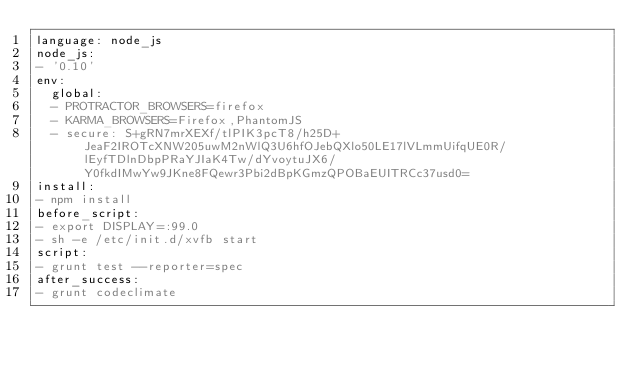<code> <loc_0><loc_0><loc_500><loc_500><_YAML_>language: node_js
node_js:
- '0.10'
env:
  global:
  - PROTRACTOR_BROWSERS=firefox
  - KARMA_BROWSERS=Firefox,PhantomJS
  - secure: S+gRN7mrXEXf/tlPIK3pcT8/h25D+JeaF2IROTcXNW205uwM2nWlQ3U6hfOJebQXlo50LE17lVLmmUifqUE0R/lEyfTDlnDbpPRaYJIaK4Tw/dYvoytuJX6/Y0fkdIMwYw9JKne8FQewr3Pbi2dBpKGmzQPOBaEUITRCc37usd0=
install:
- npm install
before_script:
- export DISPLAY=:99.0
- sh -e /etc/init.d/xvfb start
script:
- grunt test --reporter=spec
after_success:
- grunt codeclimate
</code> 